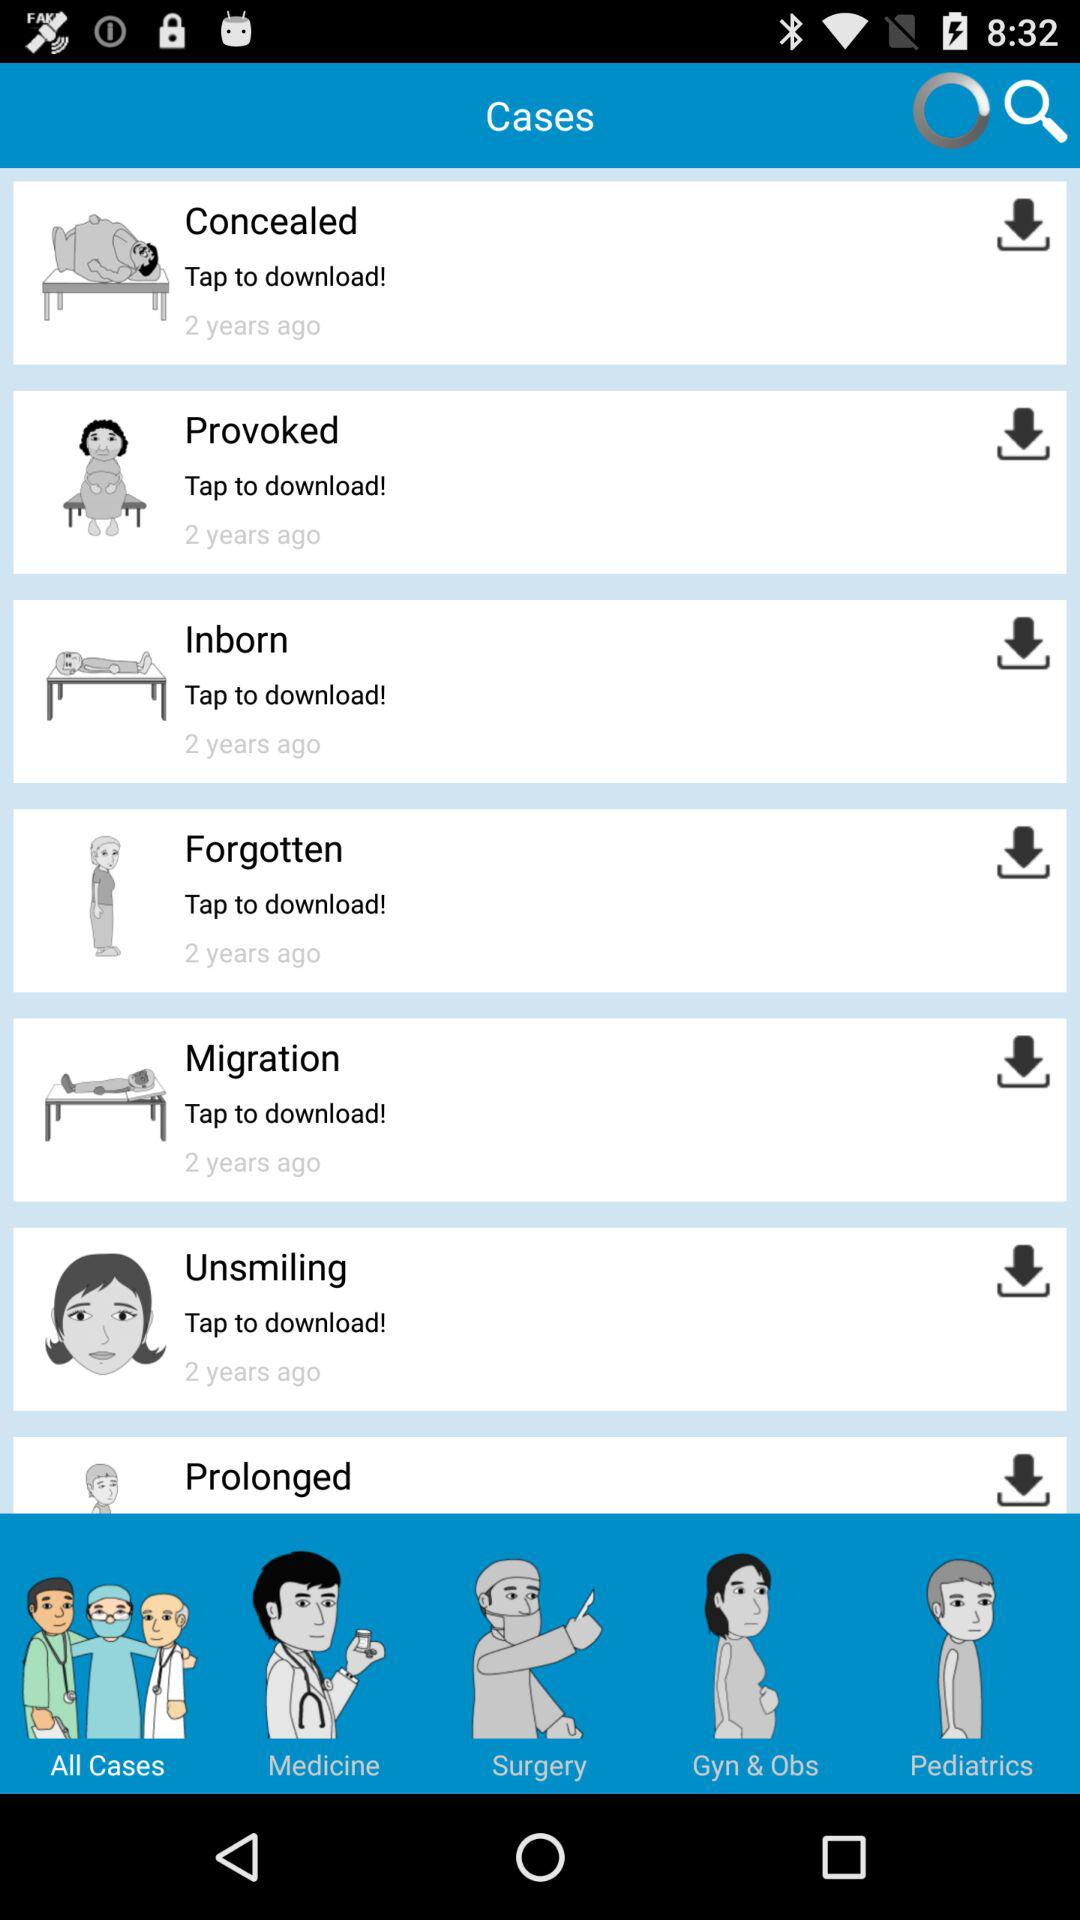How many years ago was the case "Provoked" uploaded? The case "Provoked" was uploaded 2 years ago. 